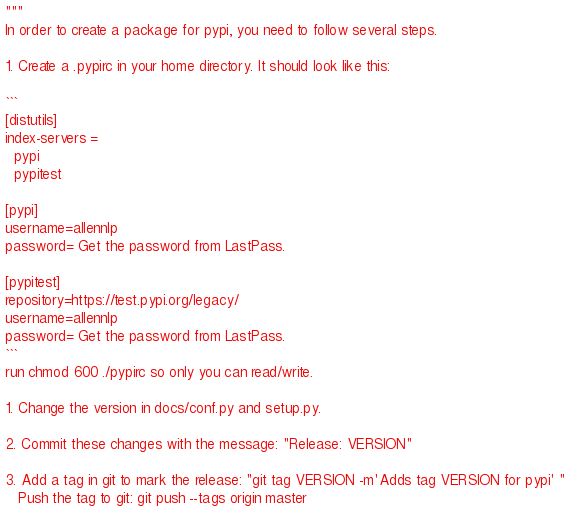<code> <loc_0><loc_0><loc_500><loc_500><_Python_>"""
In order to create a package for pypi, you need to follow several steps.

1. Create a .pypirc in your home directory. It should look like this:

```
[distutils]
index-servers =
  pypi
  pypitest

[pypi]
username=allennlp
password= Get the password from LastPass.

[pypitest]
repository=https://test.pypi.org/legacy/
username=allennlp
password= Get the password from LastPass.
```
run chmod 600 ./pypirc so only you can read/write.

1. Change the version in docs/conf.py and setup.py.

2. Commit these changes with the message: "Release: VERSION"

3. Add a tag in git to mark the release: "git tag VERSION -m'Adds tag VERSION for pypi' "
   Push the tag to git: git push --tags origin master
</code> 